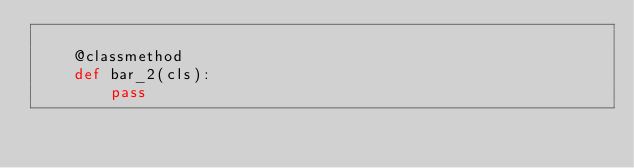Convert code to text. <code><loc_0><loc_0><loc_500><loc_500><_Python_>
    @classmethod
    def bar_2(cls):
        pass
</code> 